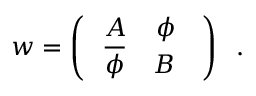Convert formula to latex. <formula><loc_0><loc_0><loc_500><loc_500>w = \left ( \begin{array} { c c } { \, A \, \phi \, } \\ { { \, { \overline { \phi } } \, B \, } } \end{array} \right ) \, .</formula> 